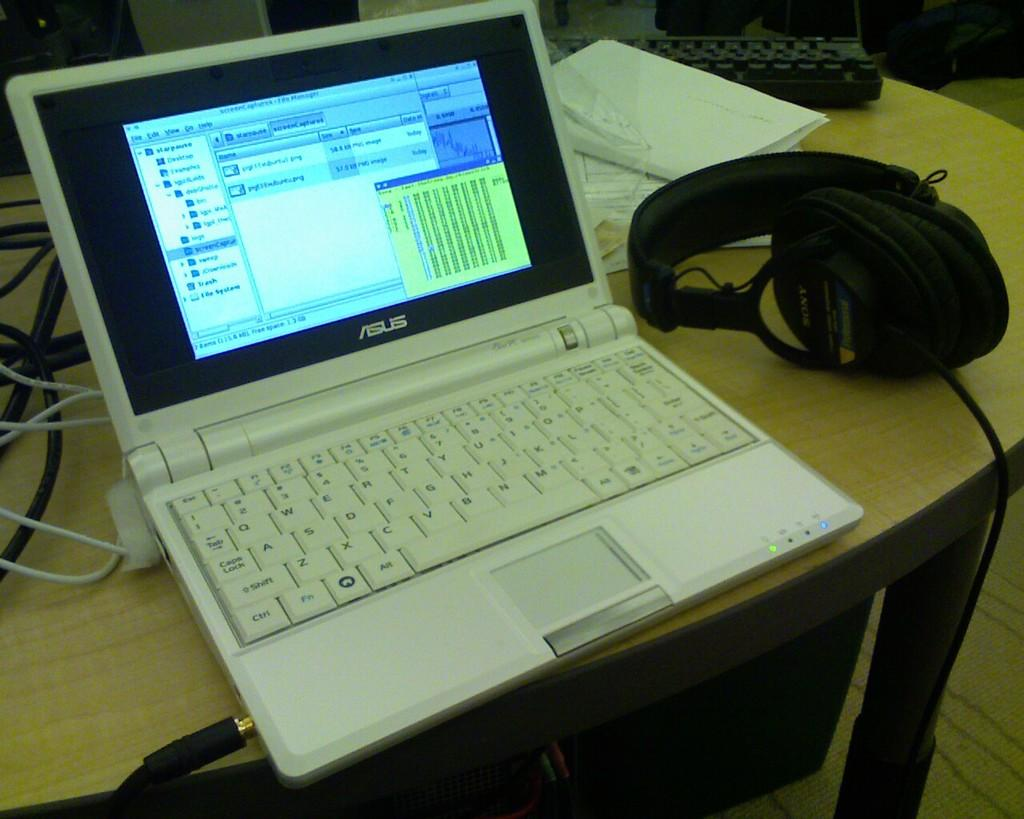<image>
Relay a brief, clear account of the picture shown. A white Asus laptop sits on a desk next to headphones. 